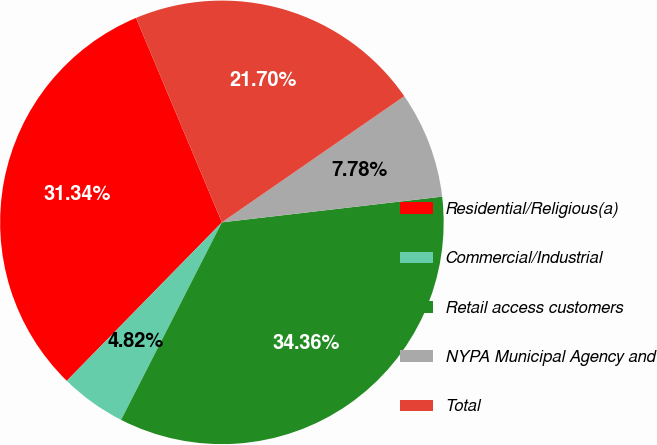<chart> <loc_0><loc_0><loc_500><loc_500><pie_chart><fcel>Residential/Religious(a)<fcel>Commercial/Industrial<fcel>Retail access customers<fcel>NYPA Municipal Agency and<fcel>Total<nl><fcel>31.34%<fcel>4.82%<fcel>34.36%<fcel>7.78%<fcel>21.7%<nl></chart> 